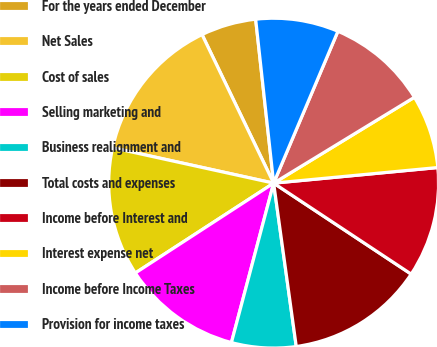<chart> <loc_0><loc_0><loc_500><loc_500><pie_chart><fcel>For the years ended December<fcel>Net Sales<fcel>Cost of sales<fcel>Selling marketing and<fcel>Business realignment and<fcel>Total costs and expenses<fcel>Income before Interest and<fcel>Interest expense net<fcel>Income before Income Taxes<fcel>Provision for income taxes<nl><fcel>5.41%<fcel>14.41%<fcel>12.61%<fcel>11.71%<fcel>6.31%<fcel>13.51%<fcel>10.81%<fcel>7.21%<fcel>9.91%<fcel>8.11%<nl></chart> 